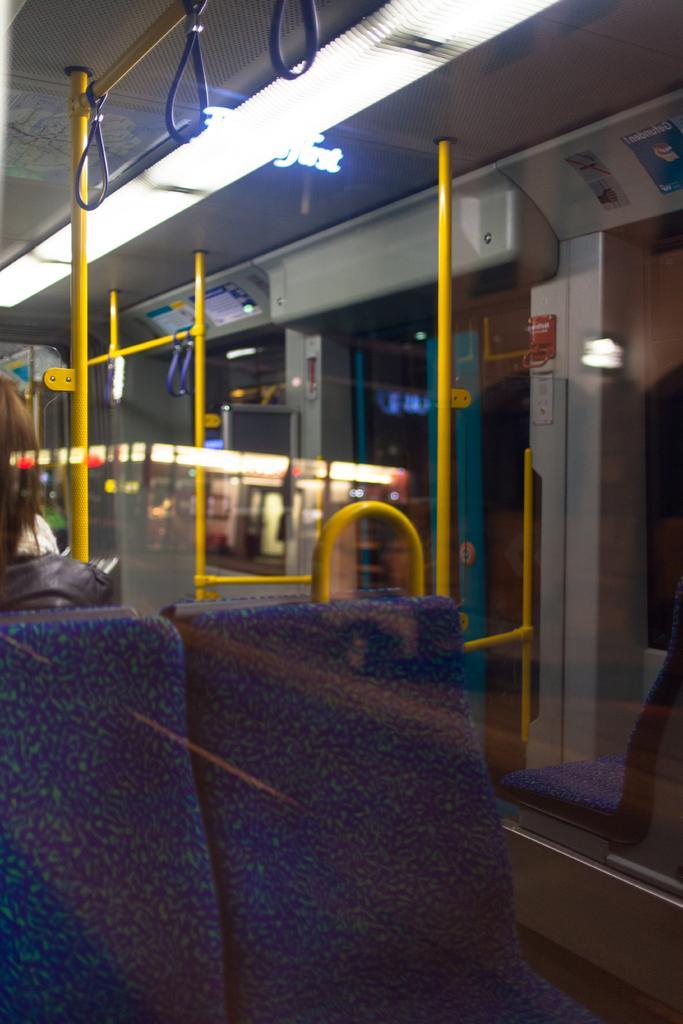How would you summarize this image in a sentence or two? In the foreground of this image, through the glass, we can see seats, a woman sitting on the seat, few yellow colored poles, glass windows and the door. On the top, there are few hand holding objects and lights. We can also see the reflection of lights in the glass. 